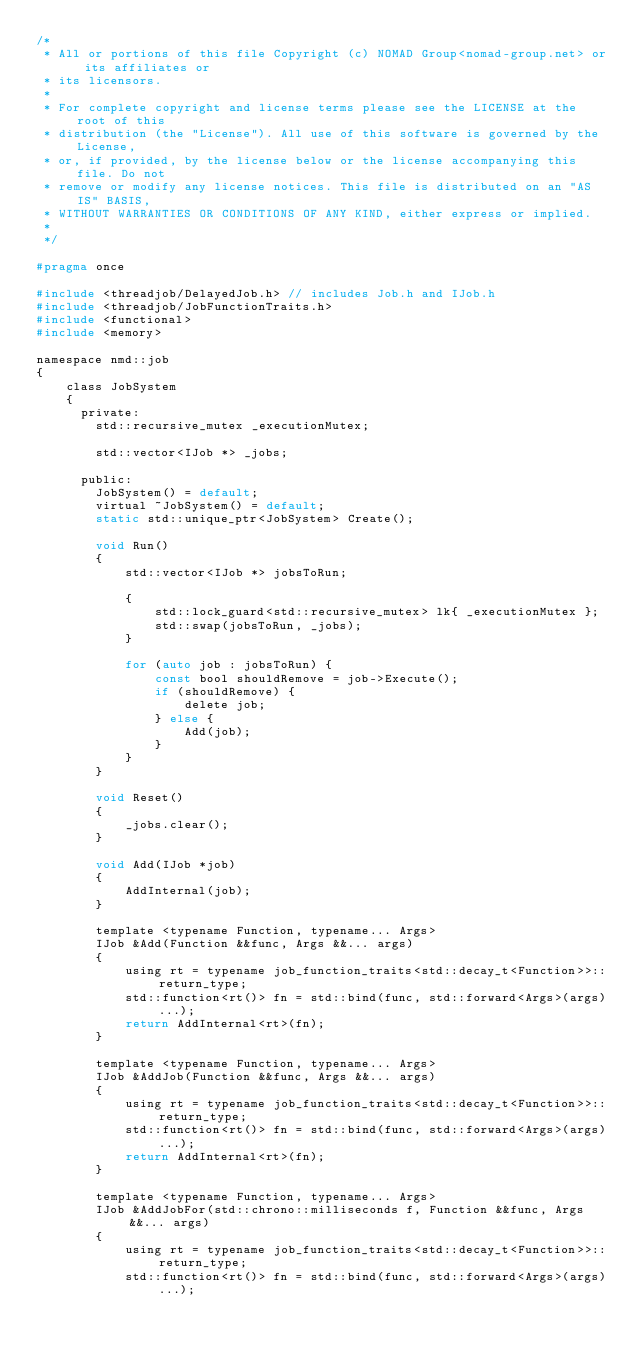<code> <loc_0><loc_0><loc_500><loc_500><_C_>/*
 * All or portions of this file Copyright (c) NOMAD Group<nomad-group.net> or its affiliates or
 * its licensors.
 *
 * For complete copyright and license terms please see the LICENSE at the root of this
 * distribution (the "License"). All use of this software is governed by the License,
 * or, if provided, by the license below or the license accompanying this file. Do not
 * remove or modify any license notices. This file is distributed on an "AS IS" BASIS,
 * WITHOUT WARRANTIES OR CONDITIONS OF ANY KIND, either express or implied.
 *
 */

#pragma once

#include <threadjob/DelayedJob.h> // includes Job.h and IJob.h
#include <threadjob/JobFunctionTraits.h>
#include <functional>
#include <memory>

namespace nmd::job
{
	class JobSystem
	{
	  private:
		std::recursive_mutex _executionMutex;

		std::vector<IJob *> _jobs;

	  public:
		JobSystem() = default;
		virtual ~JobSystem() = default;
		static std::unique_ptr<JobSystem> Create();

		void Run()
		{
			std::vector<IJob *> jobsToRun;

			{
				std::lock_guard<std::recursive_mutex> lk{ _executionMutex };
				std::swap(jobsToRun, _jobs);
			}

			for (auto job : jobsToRun) {
				const bool shouldRemove = job->Execute();
				if (shouldRemove) {
					delete job;
				} else {
					Add(job);
				}
			}
		}

		void Reset()
		{
			_jobs.clear();
		}

		void Add(IJob *job)
		{
			AddInternal(job);
		}

		template <typename Function, typename... Args>
		IJob &Add(Function &&func, Args &&... args)
		{
			using rt = typename job_function_traits<std::decay_t<Function>>::return_type;
			std::function<rt()> fn = std::bind(func, std::forward<Args>(args)...);
			return AddInternal<rt>(fn);
		}
		
		template <typename Function, typename... Args>
		IJob &AddJob(Function &&func, Args &&... args)
		{
			using rt = typename job_function_traits<std::decay_t<Function>>::return_type;
			std::function<rt()> fn = std::bind(func, std::forward<Args>(args)...);
			return AddInternal<rt>(fn);
		}

		template <typename Function, typename... Args>
		IJob &AddJobFor(std::chrono::milliseconds f, Function &&func, Args &&... args)
		{
			using rt = typename job_function_traits<std::decay_t<Function>>::return_type;
			std::function<rt()> fn = std::bind(func, std::forward<Args>(args)...);
</code> 